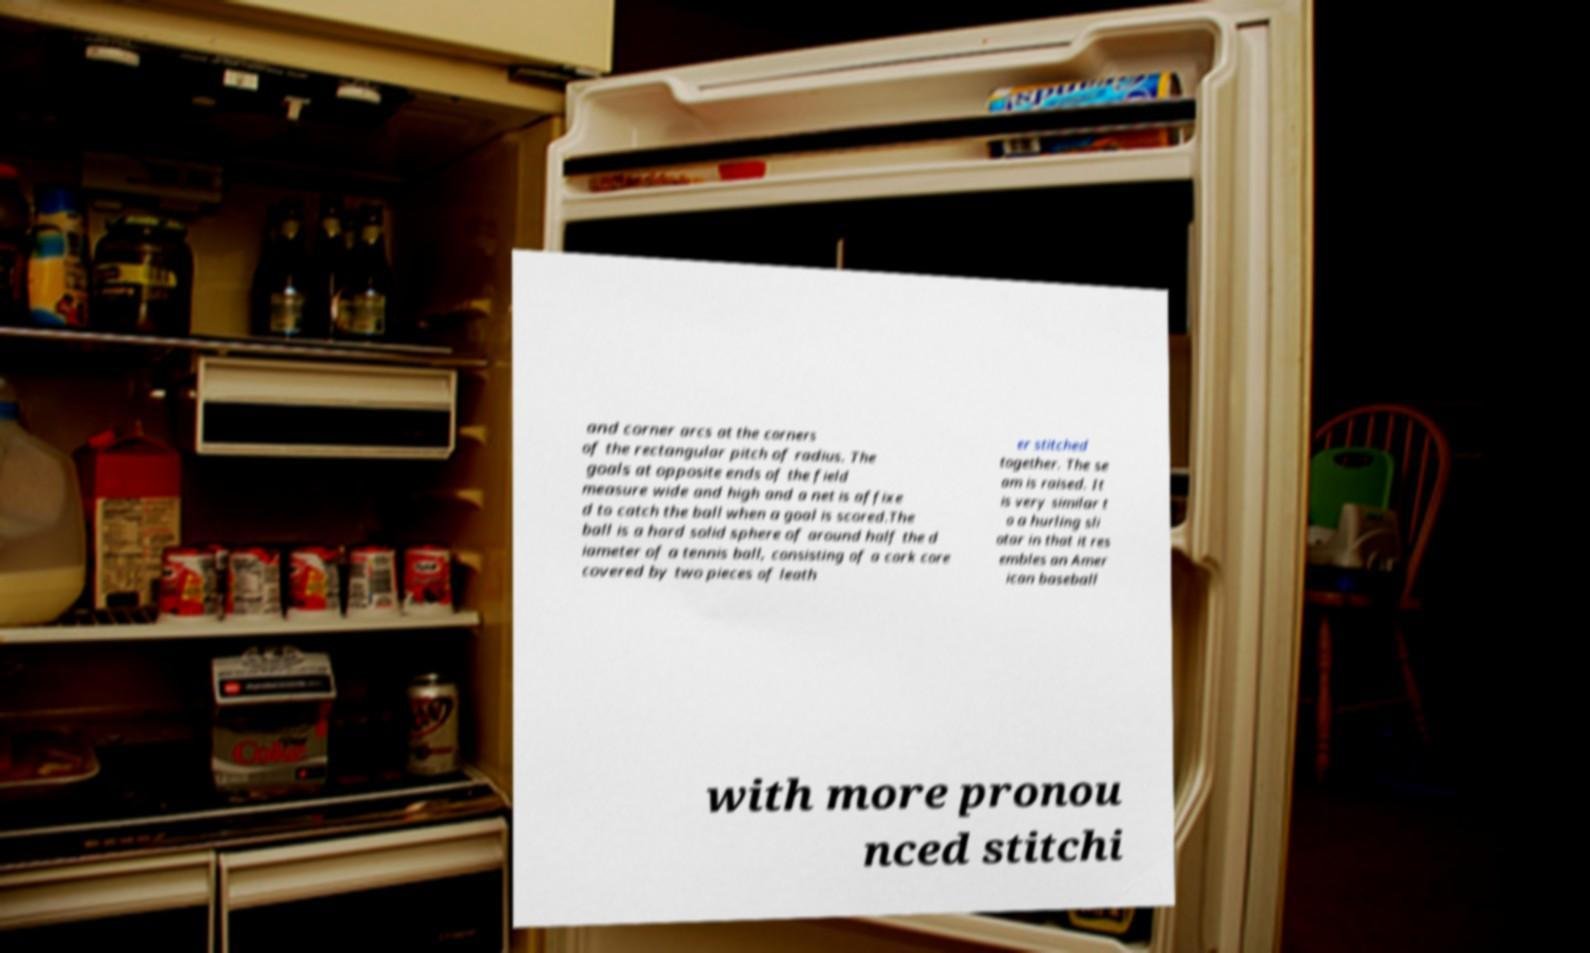What messages or text are displayed in this image? I need them in a readable, typed format. and corner arcs at the corners of the rectangular pitch of radius. The goals at opposite ends of the field measure wide and high and a net is affixe d to catch the ball when a goal is scored.The ball is a hard solid sphere of around half the d iameter of a tennis ball, consisting of a cork core covered by two pieces of leath er stitched together. The se am is raised. It is very similar t o a hurling sli otar in that it res embles an Amer ican baseball with more pronou nced stitchi 